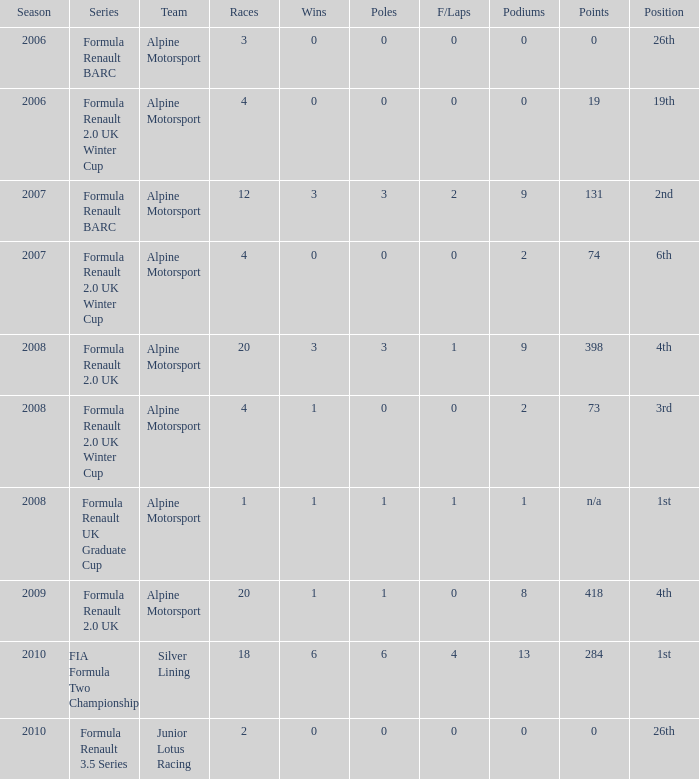What was the earliest season where podium was 9? 2007.0. 